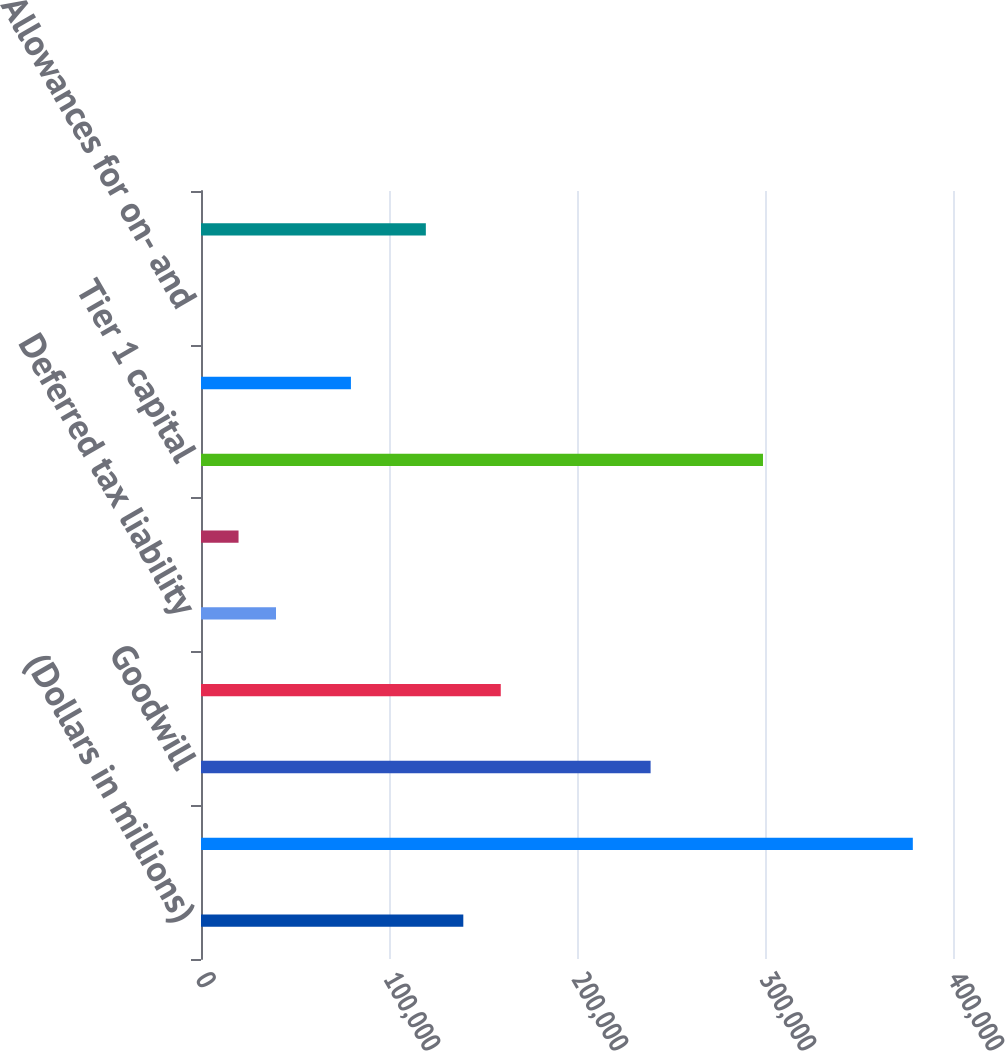Convert chart to OTSL. <chart><loc_0><loc_0><loc_500><loc_500><bar_chart><fcel>(Dollars in millions)<fcel>Total common shareholders'<fcel>Goodwill<fcel>Other intangible assets<fcel>Deferred tax liability<fcel>Other<fcel>Tier 1 capital<fcel>Qualifying subordinated debt<fcel>Allowances for on- and<fcel>Tier 2 capital<nl><fcel>139524<fcel>378631<fcel>239152<fcel>159450<fcel>39896.2<fcel>19970.6<fcel>298929<fcel>79747.4<fcel>45<fcel>119599<nl></chart> 